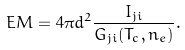Convert formula to latex. <formula><loc_0><loc_0><loc_500><loc_500>E M = 4 \pi d ^ { 2 } \frac { I _ { j i } } { G _ { j i } ( T _ { c } , n _ { e } ) } .</formula> 